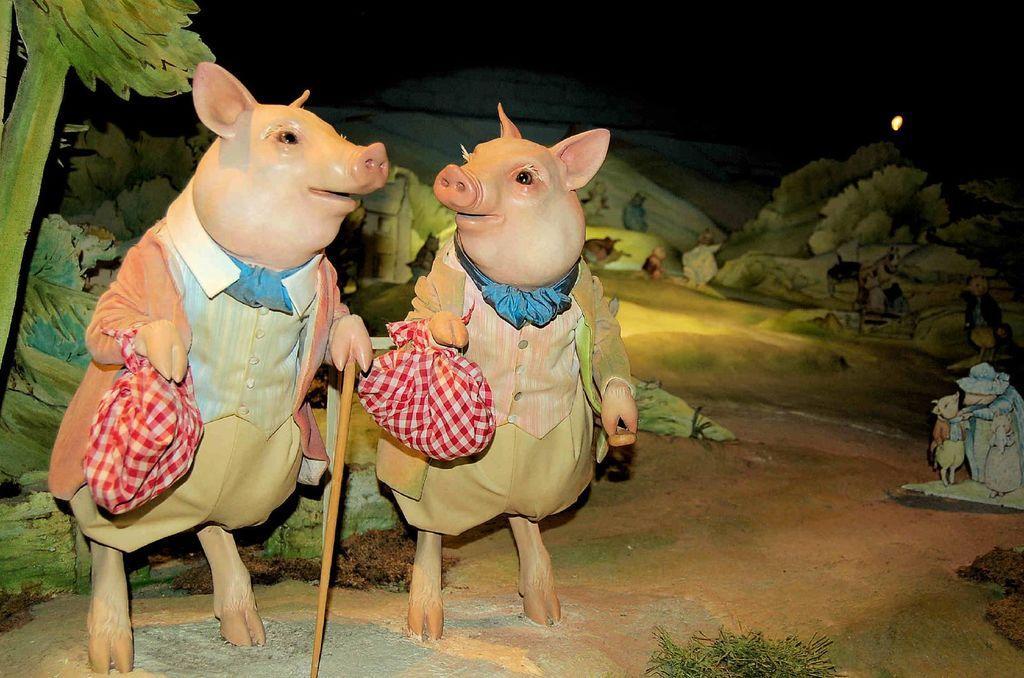How would you summarize this image in a sentence or two? In this picture there are two toy pigs on the left side of the image and there are toy trees in the background area of the image. 